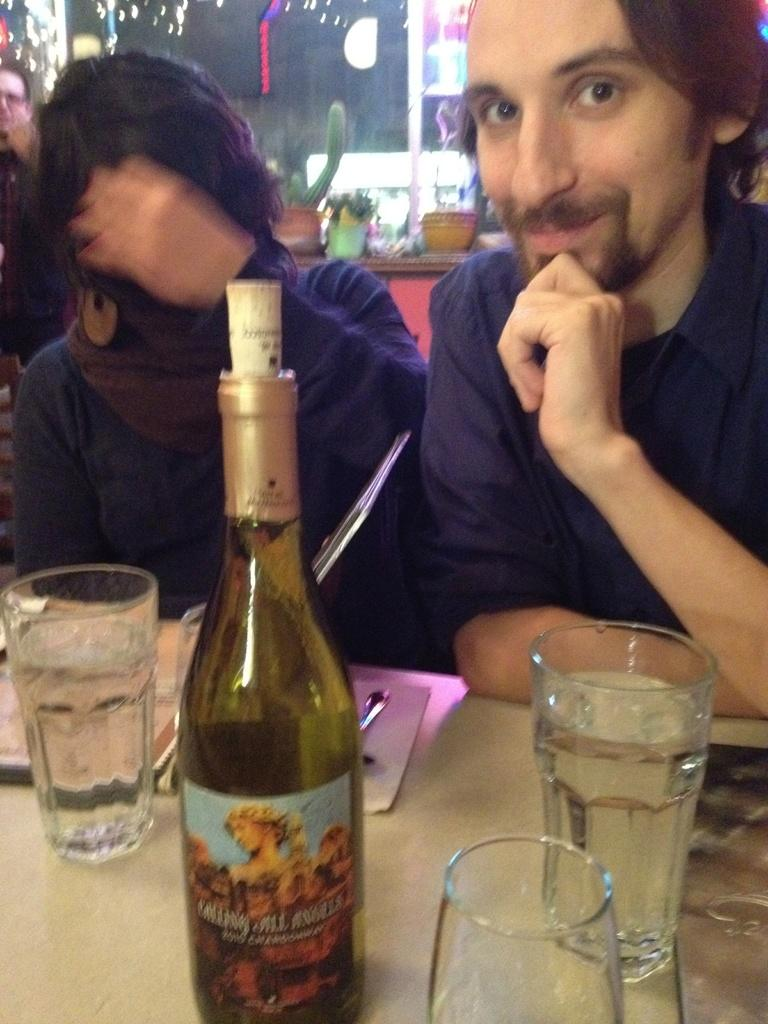What can be seen in the image that is typically used for holding liquids? There is a bottle in the image. What objects are on the table in the image? There are three glasses on a table. What can be seen in the background of the image? There are two persons sitting in the background and a small plant. Is there another glass visible in the image besides the ones on the table? Yes, there is a glass in the background. What songs is the grandmother singing in the image? There is no grandmother or singing present in the image. 